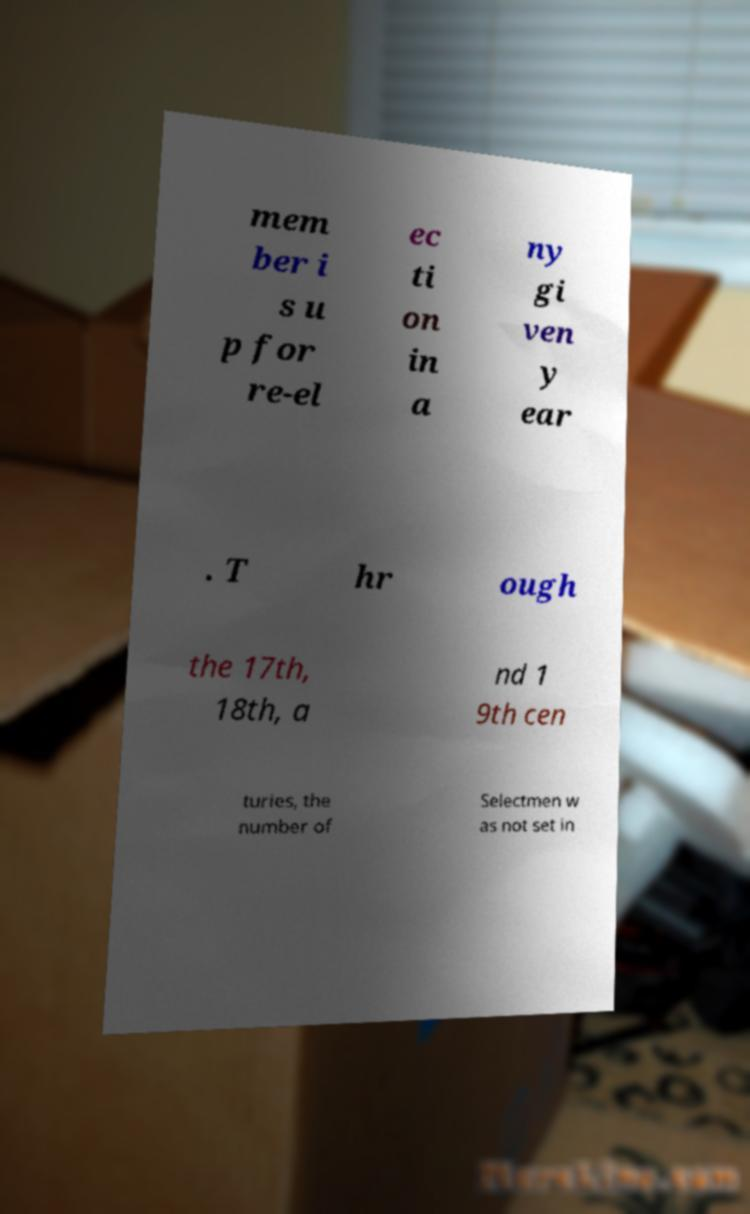I need the written content from this picture converted into text. Can you do that? mem ber i s u p for re-el ec ti on in a ny gi ven y ear . T hr ough the 17th, 18th, a nd 1 9th cen turies, the number of Selectmen w as not set in 